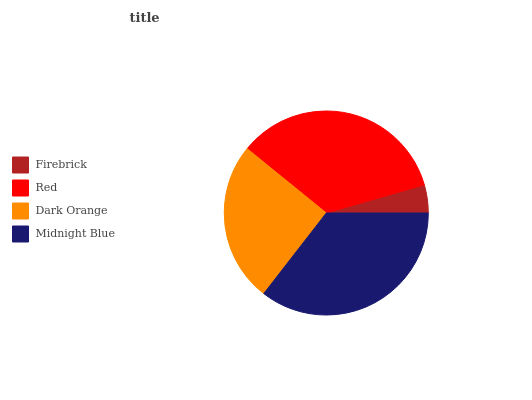Is Firebrick the minimum?
Answer yes or no. Yes. Is Midnight Blue the maximum?
Answer yes or no. Yes. Is Red the minimum?
Answer yes or no. No. Is Red the maximum?
Answer yes or no. No. Is Red greater than Firebrick?
Answer yes or no. Yes. Is Firebrick less than Red?
Answer yes or no. Yes. Is Firebrick greater than Red?
Answer yes or no. No. Is Red less than Firebrick?
Answer yes or no. No. Is Red the high median?
Answer yes or no. Yes. Is Dark Orange the low median?
Answer yes or no. Yes. Is Firebrick the high median?
Answer yes or no. No. Is Midnight Blue the low median?
Answer yes or no. No. 